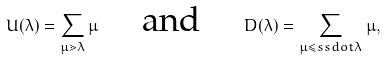<formula> <loc_0><loc_0><loc_500><loc_500>U ( \lambda ) = \sum _ { \mu \gtrdot \lambda } \mu \quad \text { and } \quad D ( \lambda ) = \sum _ { \mu \leq s s d o t \lambda } \mu ,</formula> 